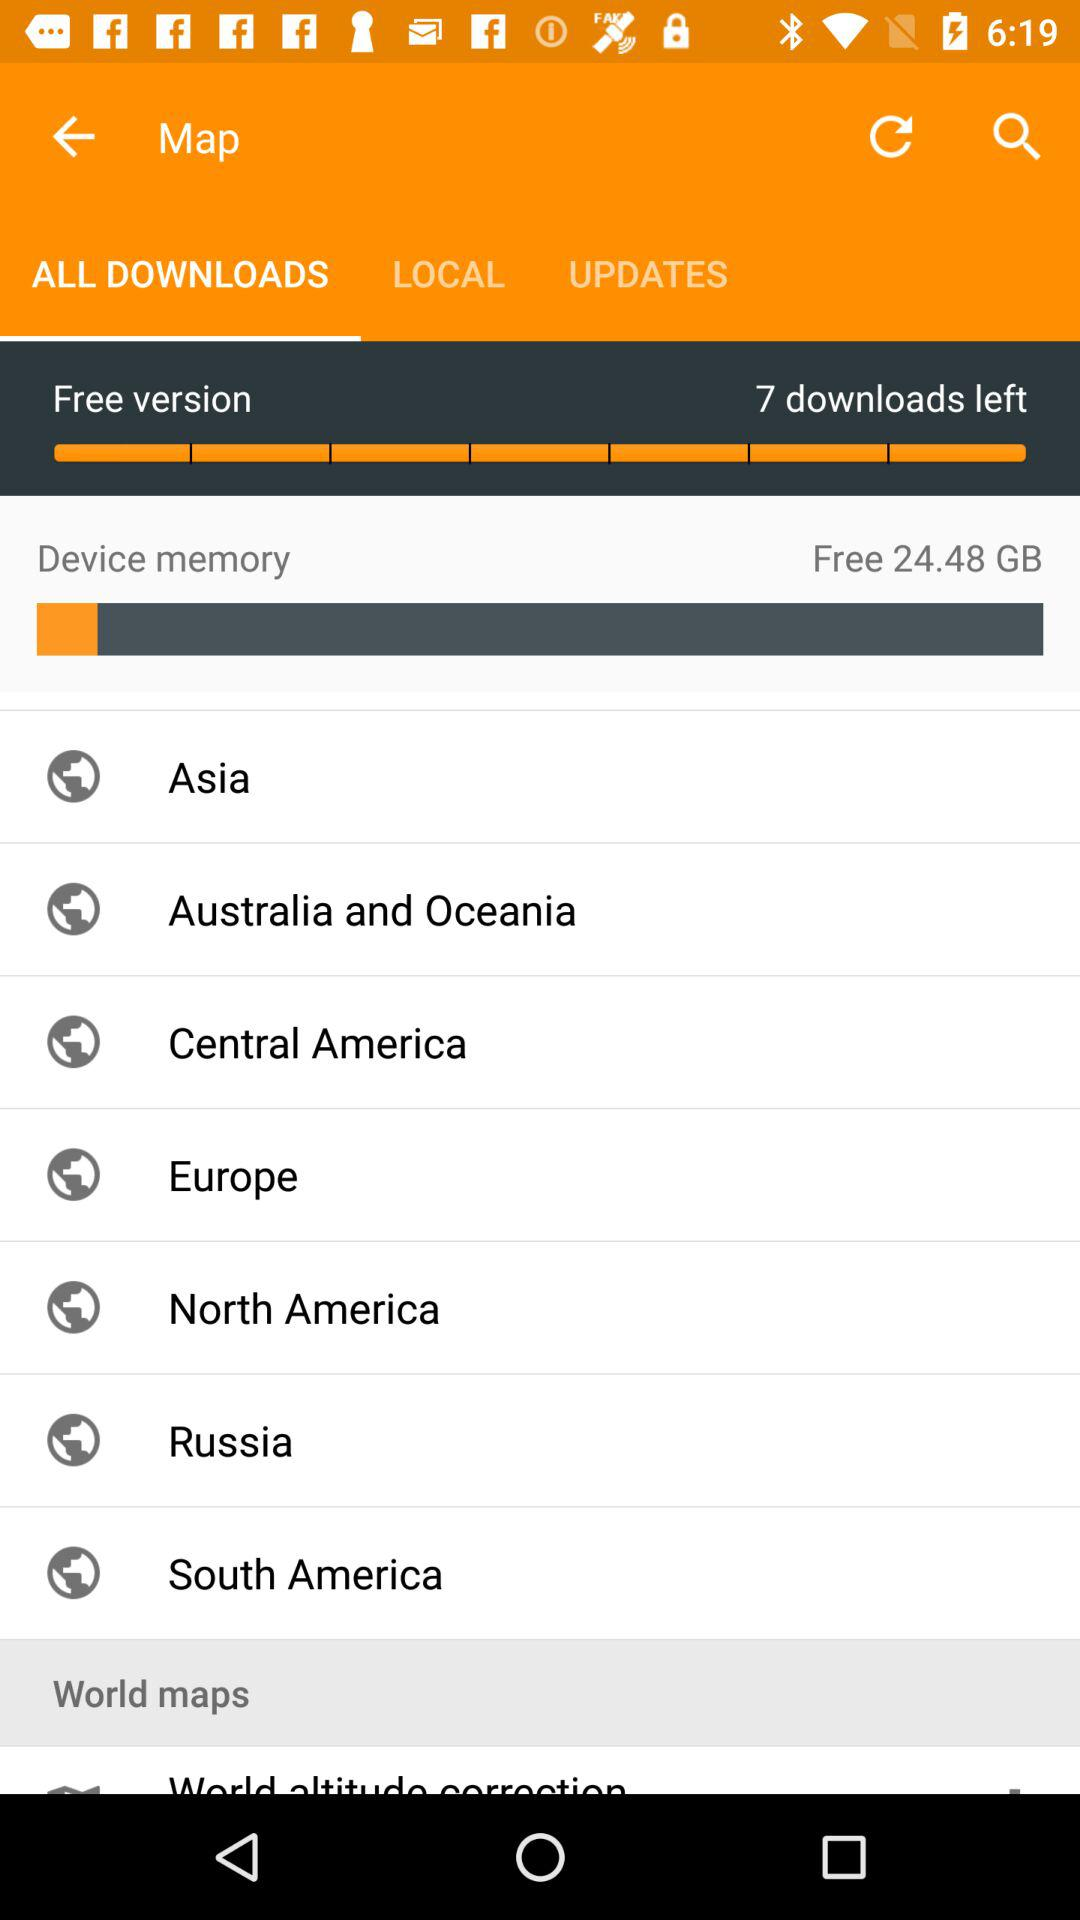How much free space is there in the device memory? There is 24.48 GB of free space in the device memory. 